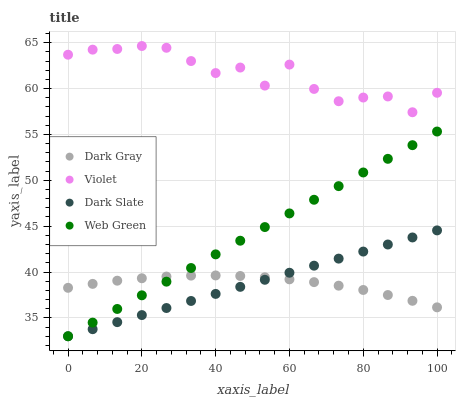Does Dark Gray have the minimum area under the curve?
Answer yes or no. Yes. Does Violet have the maximum area under the curve?
Answer yes or no. Yes. Does Dark Slate have the minimum area under the curve?
Answer yes or no. No. Does Dark Slate have the maximum area under the curve?
Answer yes or no. No. Is Dark Slate the smoothest?
Answer yes or no. Yes. Is Violet the roughest?
Answer yes or no. Yes. Is Web Green the smoothest?
Answer yes or no. No. Is Web Green the roughest?
Answer yes or no. No. Does Dark Slate have the lowest value?
Answer yes or no. Yes. Does Violet have the lowest value?
Answer yes or no. No. Does Violet have the highest value?
Answer yes or no. Yes. Does Dark Slate have the highest value?
Answer yes or no. No. Is Dark Gray less than Violet?
Answer yes or no. Yes. Is Violet greater than Dark Gray?
Answer yes or no. Yes. Does Dark Gray intersect Dark Slate?
Answer yes or no. Yes. Is Dark Gray less than Dark Slate?
Answer yes or no. No. Is Dark Gray greater than Dark Slate?
Answer yes or no. No. Does Dark Gray intersect Violet?
Answer yes or no. No. 